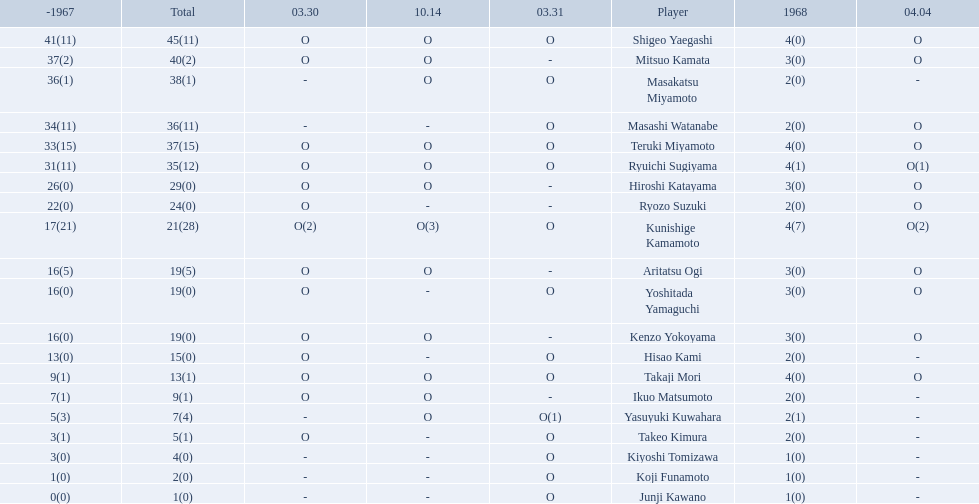Who are all of the players? Shigeo Yaegashi, Mitsuo Kamata, Masakatsu Miyamoto, Masashi Watanabe, Teruki Miyamoto, Ryuichi Sugiyama, Hiroshi Katayama, Ryozo Suzuki, Kunishige Kamamoto, Aritatsu Ogi, Yoshitada Yamaguchi, Kenzo Yokoyama, Hisao Kami, Takaji Mori, Ikuo Matsumoto, Yasuyuki Kuwahara, Takeo Kimura, Kiyoshi Tomizawa, Koji Funamoto, Junji Kawano. How many points did they receive? 45(11), 40(2), 38(1), 36(11), 37(15), 35(12), 29(0), 24(0), 21(28), 19(5), 19(0), 19(0), 15(0), 13(1), 9(1), 7(4), 5(1), 4(0), 2(0), 1(0). What about just takaji mori and junji kawano? 13(1), 1(0). Of the two, who had more points? Takaji Mori. 